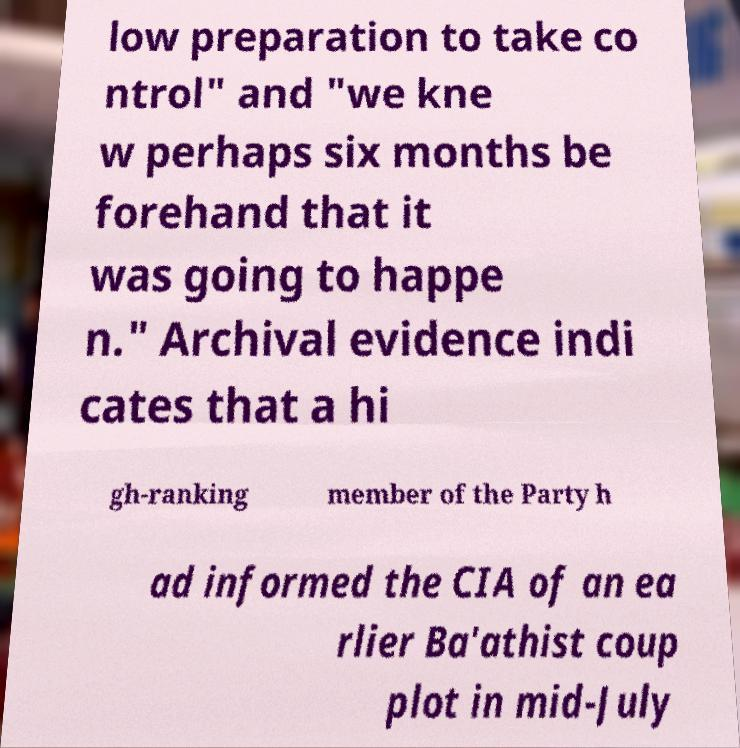There's text embedded in this image that I need extracted. Can you transcribe it verbatim? low preparation to take co ntrol" and "we kne w perhaps six months be forehand that it was going to happe n." Archival evidence indi cates that a hi gh-ranking member of the Party h ad informed the CIA of an ea rlier Ba'athist coup plot in mid-July 